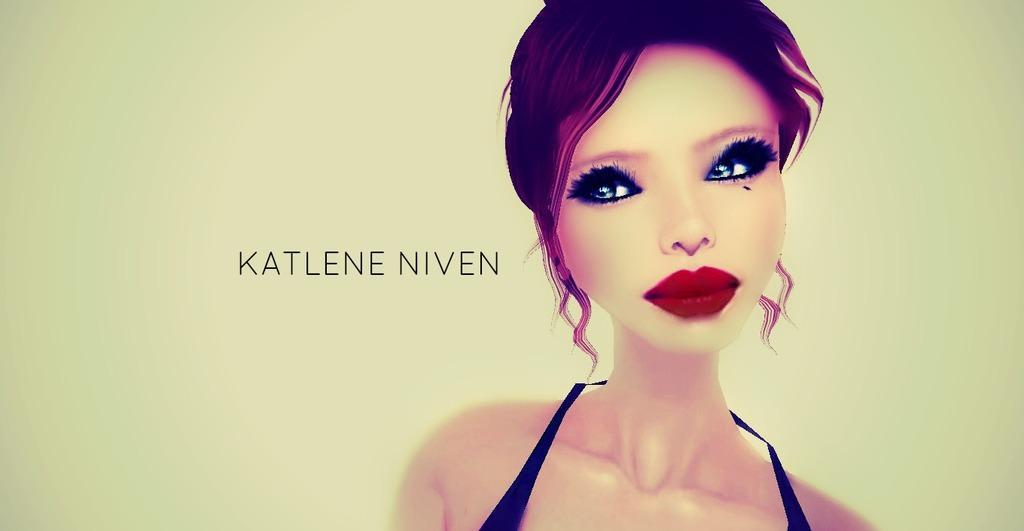Please provide a concise description of this image. This image consists of an animated image. In which we can see a depiction of a woman along with text. 